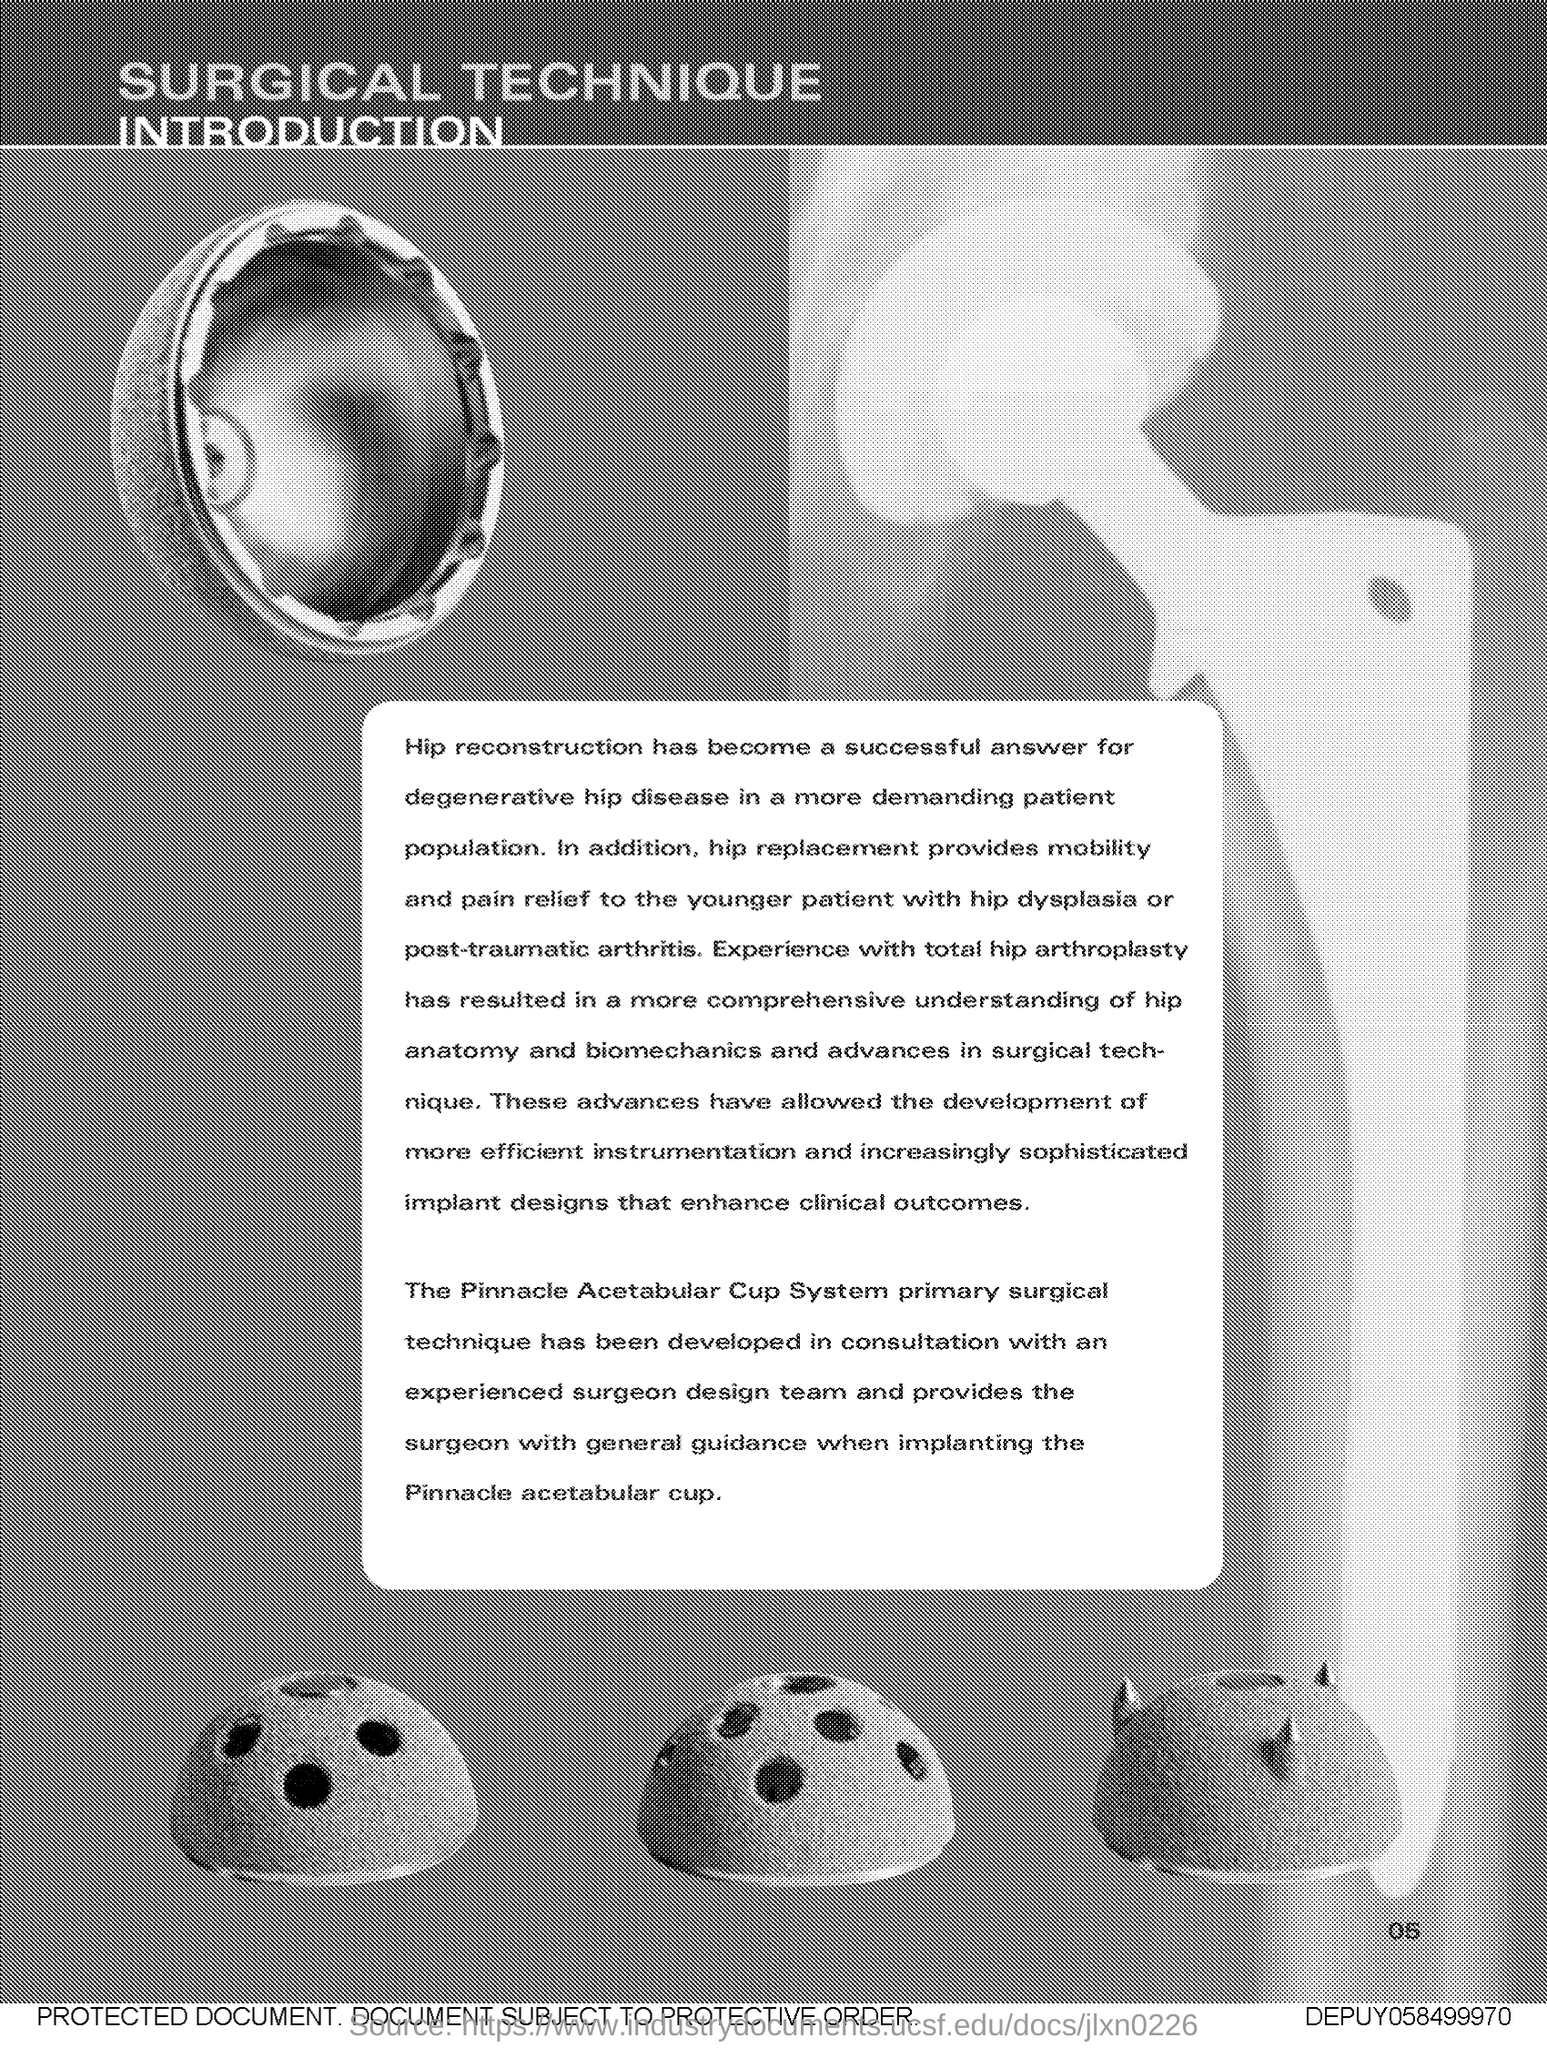Give some essential details in this illustration. Hip replacement is a procedure that provides mobility and pain relief to younger patients suffering from hip dysplasia or post-traumatic arthritis. The title of the document is 'Surgical Technique.' The successful treatment option for degenerative hip disease is hip reconstruction, which involves surgical procedures to repair or replace damaged or diseased hip joint tissue. This approach can help alleviate pain, improve mobility, and provide long-term relief for individuals affected by this condition. The result of my experience with total hip arthroplasty was a more comprehensive understanding of hip anatomy. 